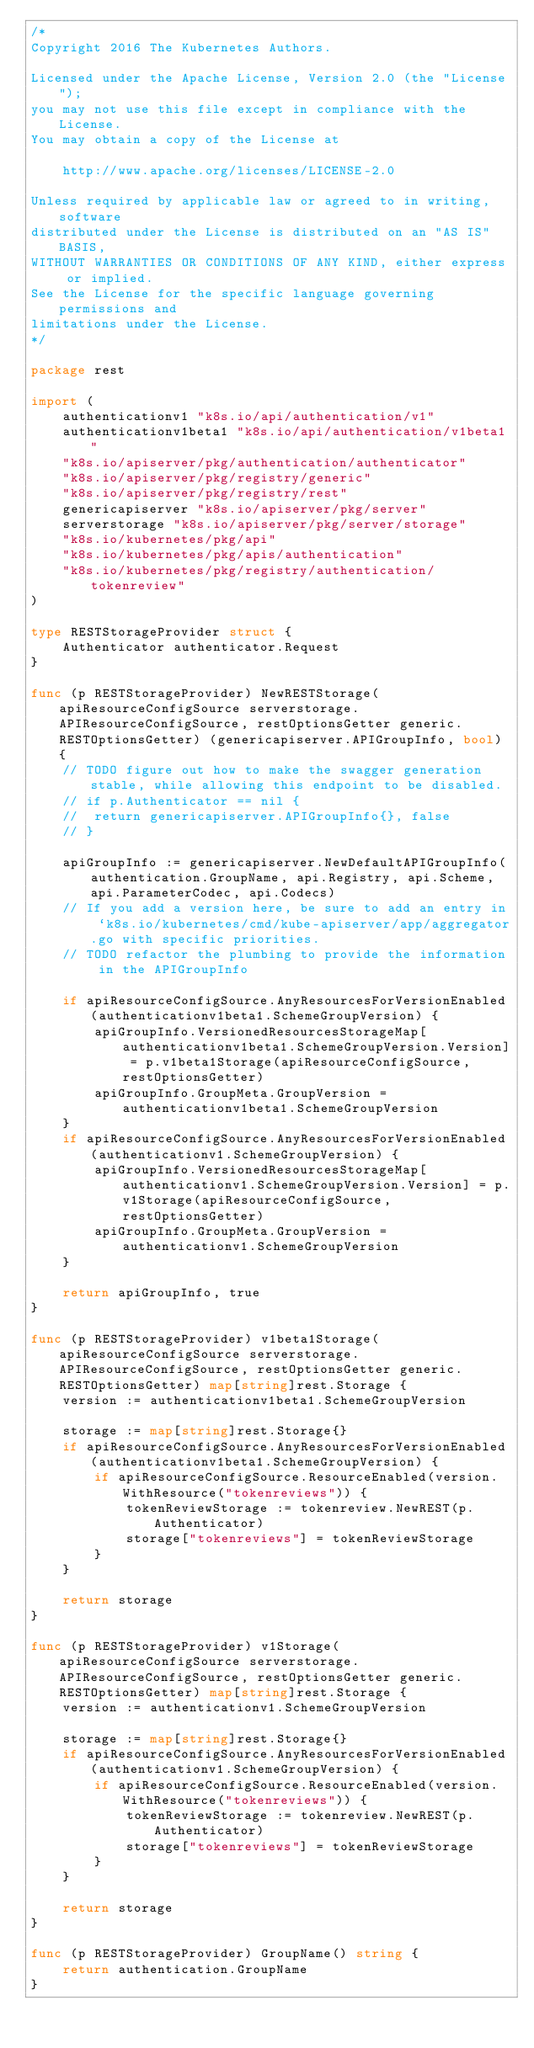Convert code to text. <code><loc_0><loc_0><loc_500><loc_500><_Go_>/*
Copyright 2016 The Kubernetes Authors.

Licensed under the Apache License, Version 2.0 (the "License");
you may not use this file except in compliance with the License.
You may obtain a copy of the License at

    http://www.apache.org/licenses/LICENSE-2.0

Unless required by applicable law or agreed to in writing, software
distributed under the License is distributed on an "AS IS" BASIS,
WITHOUT WARRANTIES OR CONDITIONS OF ANY KIND, either express or implied.
See the License for the specific language governing permissions and
limitations under the License.
*/

package rest

import (
	authenticationv1 "k8s.io/api/authentication/v1"
	authenticationv1beta1 "k8s.io/api/authentication/v1beta1"
	"k8s.io/apiserver/pkg/authentication/authenticator"
	"k8s.io/apiserver/pkg/registry/generic"
	"k8s.io/apiserver/pkg/registry/rest"
	genericapiserver "k8s.io/apiserver/pkg/server"
	serverstorage "k8s.io/apiserver/pkg/server/storage"
	"k8s.io/kubernetes/pkg/api"
	"k8s.io/kubernetes/pkg/apis/authentication"
	"k8s.io/kubernetes/pkg/registry/authentication/tokenreview"
)

type RESTStorageProvider struct {
	Authenticator authenticator.Request
}

func (p RESTStorageProvider) NewRESTStorage(apiResourceConfigSource serverstorage.APIResourceConfigSource, restOptionsGetter generic.RESTOptionsGetter) (genericapiserver.APIGroupInfo, bool) {
	// TODO figure out how to make the swagger generation stable, while allowing this endpoint to be disabled.
	// if p.Authenticator == nil {
	// 	return genericapiserver.APIGroupInfo{}, false
	// }

	apiGroupInfo := genericapiserver.NewDefaultAPIGroupInfo(authentication.GroupName, api.Registry, api.Scheme, api.ParameterCodec, api.Codecs)
	// If you add a version here, be sure to add an entry in `k8s.io/kubernetes/cmd/kube-apiserver/app/aggregator.go with specific priorities.
	// TODO refactor the plumbing to provide the information in the APIGroupInfo

	if apiResourceConfigSource.AnyResourcesForVersionEnabled(authenticationv1beta1.SchemeGroupVersion) {
		apiGroupInfo.VersionedResourcesStorageMap[authenticationv1beta1.SchemeGroupVersion.Version] = p.v1beta1Storage(apiResourceConfigSource, restOptionsGetter)
		apiGroupInfo.GroupMeta.GroupVersion = authenticationv1beta1.SchemeGroupVersion
	}
	if apiResourceConfigSource.AnyResourcesForVersionEnabled(authenticationv1.SchemeGroupVersion) {
		apiGroupInfo.VersionedResourcesStorageMap[authenticationv1.SchemeGroupVersion.Version] = p.v1Storage(apiResourceConfigSource, restOptionsGetter)
		apiGroupInfo.GroupMeta.GroupVersion = authenticationv1.SchemeGroupVersion
	}

	return apiGroupInfo, true
}

func (p RESTStorageProvider) v1beta1Storage(apiResourceConfigSource serverstorage.APIResourceConfigSource, restOptionsGetter generic.RESTOptionsGetter) map[string]rest.Storage {
	version := authenticationv1beta1.SchemeGroupVersion

	storage := map[string]rest.Storage{}
	if apiResourceConfigSource.AnyResourcesForVersionEnabled(authenticationv1beta1.SchemeGroupVersion) {
		if apiResourceConfigSource.ResourceEnabled(version.WithResource("tokenreviews")) {
			tokenReviewStorage := tokenreview.NewREST(p.Authenticator)
			storage["tokenreviews"] = tokenReviewStorage
		}
	}

	return storage
}

func (p RESTStorageProvider) v1Storage(apiResourceConfigSource serverstorage.APIResourceConfigSource, restOptionsGetter generic.RESTOptionsGetter) map[string]rest.Storage {
	version := authenticationv1.SchemeGroupVersion

	storage := map[string]rest.Storage{}
	if apiResourceConfigSource.AnyResourcesForVersionEnabled(authenticationv1.SchemeGroupVersion) {
		if apiResourceConfigSource.ResourceEnabled(version.WithResource("tokenreviews")) {
			tokenReviewStorage := tokenreview.NewREST(p.Authenticator)
			storage["tokenreviews"] = tokenReviewStorage
		}
	}

	return storage
}

func (p RESTStorageProvider) GroupName() string {
	return authentication.GroupName
}
</code> 